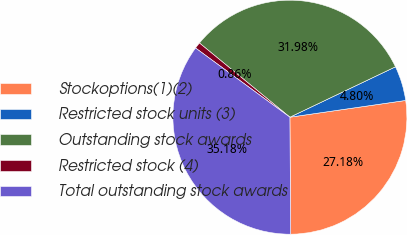Convert chart. <chart><loc_0><loc_0><loc_500><loc_500><pie_chart><fcel>Stockoptions(1)(2)<fcel>Restricted stock units (3)<fcel>Outstanding stock awards<fcel>Restricted stock (4)<fcel>Total outstanding stock awards<nl><fcel>27.18%<fcel>4.8%<fcel>31.98%<fcel>0.86%<fcel>35.18%<nl></chart> 